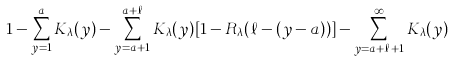Convert formula to latex. <formula><loc_0><loc_0><loc_500><loc_500>1 - \sum _ { y = 1 } ^ { a } K _ { \lambda } ( y ) - \sum _ { y = a + 1 } ^ { a + \ell } K _ { \lambda } ( y ) [ 1 - { R } _ { \lambda } ( \ell - ( y - a ) ) ] - \sum _ { y = a + \ell + 1 } ^ { \infty } K _ { \lambda } ( y )</formula> 